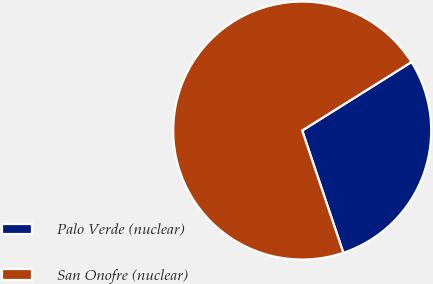Convert chart to OTSL. <chart><loc_0><loc_0><loc_500><loc_500><pie_chart><fcel>Palo Verde (nuclear)<fcel>San Onofre (nuclear)<nl><fcel>28.75%<fcel>71.25%<nl></chart> 